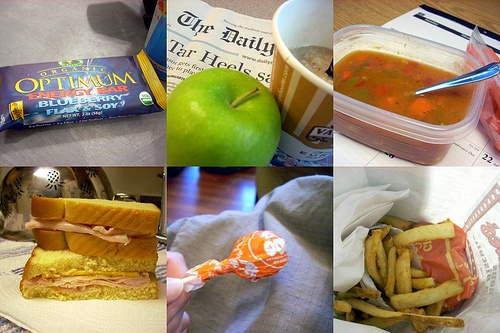Describe the objects in this image and their specific colors. I can see bowl in gray, brown, beige, and darkgray tones, sandwich in gray, olive, orange, tan, and maroon tones, apple in gray, olive, green, and khaki tones, cup in gray, darkgray, lightgray, and olive tones, and people in gray, brown, lavender, and lightpink tones in this image. 